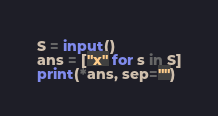Convert code to text. <code><loc_0><loc_0><loc_500><loc_500><_Python_>S = input()
ans = ["x" for s in S]
print(*ans, sep="")</code> 